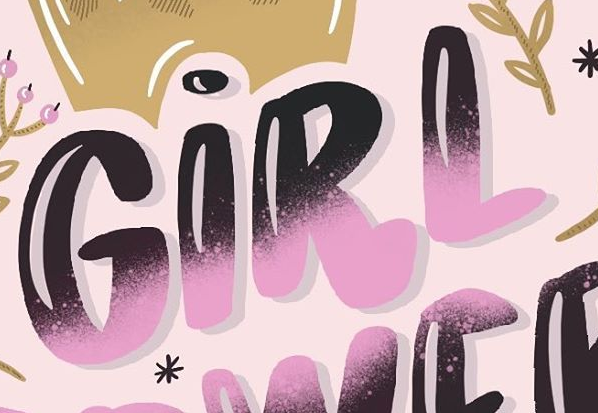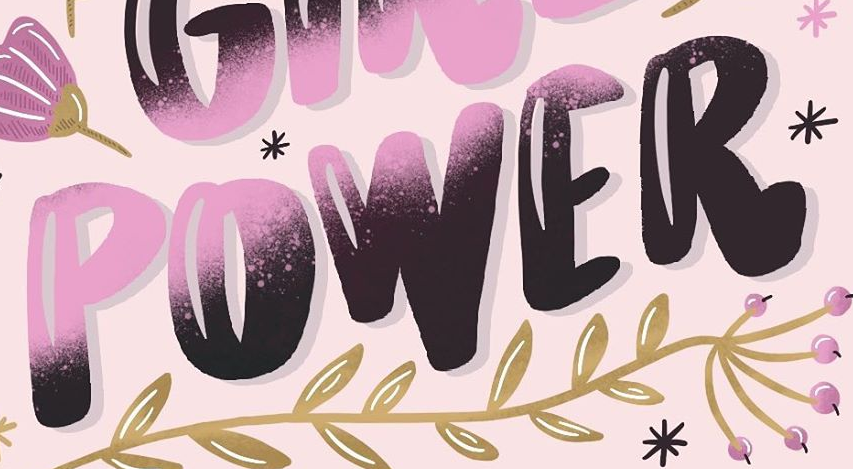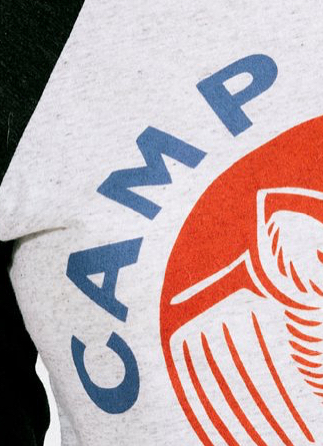Read the text content from these images in order, separated by a semicolon. GIRL; POWER; CAMP 